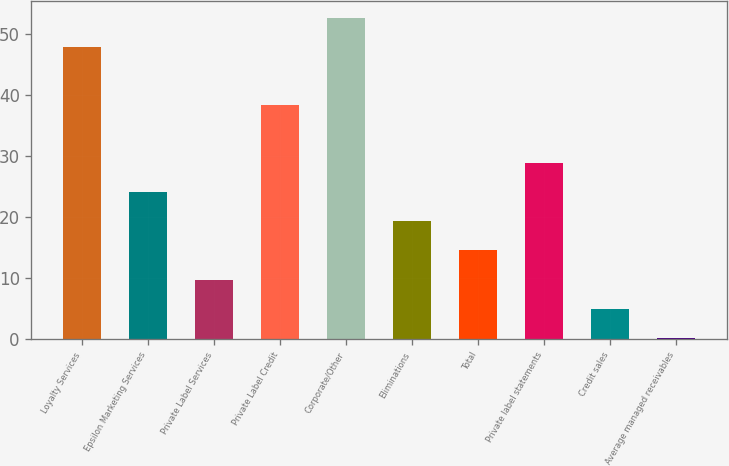<chart> <loc_0><loc_0><loc_500><loc_500><bar_chart><fcel>Loyalty Services<fcel>Epsilon Marketing Services<fcel>Private Label Services<fcel>Private Label Credit<fcel>Corporate/Other<fcel>Eliminations<fcel>Total<fcel>Private label statements<fcel>Credit sales<fcel>Average managed receivables<nl><fcel>48<fcel>24.1<fcel>9.76<fcel>38.44<fcel>52.78<fcel>19.32<fcel>14.54<fcel>28.88<fcel>4.98<fcel>0.2<nl></chart> 